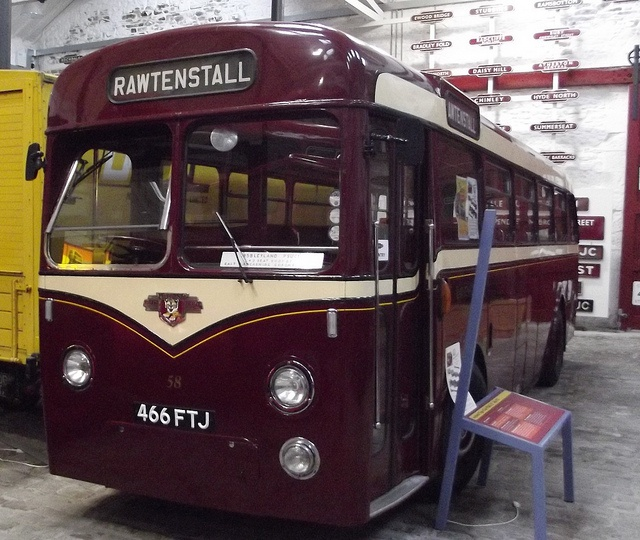Describe the objects in this image and their specific colors. I can see bus in gray, black, maroon, and darkgray tones, truck in gray, olive, gold, and black tones, and chair in gray, navy, and brown tones in this image. 